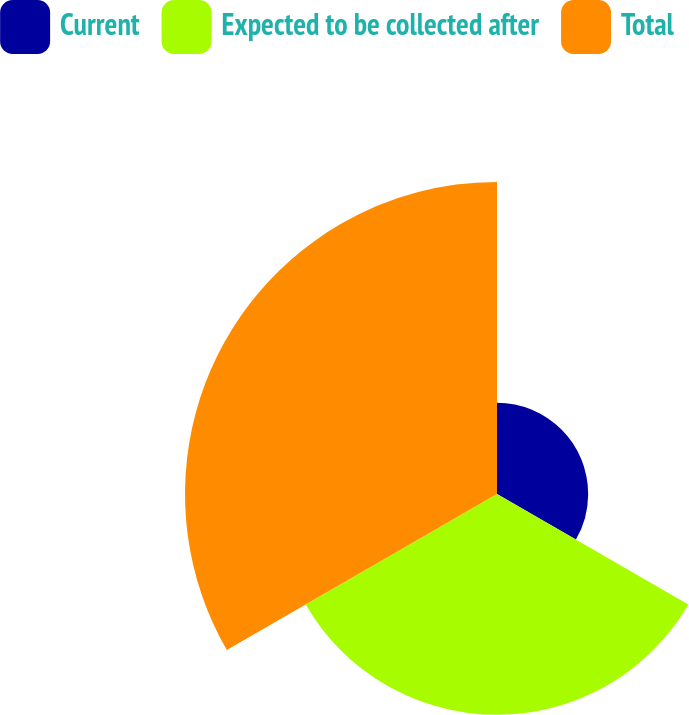Convert chart to OTSL. <chart><loc_0><loc_0><loc_500><loc_500><pie_chart><fcel>Current<fcel>Expected to be collected after<fcel>Total<nl><fcel>14.61%<fcel>35.39%<fcel>50.0%<nl></chart> 